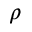<formula> <loc_0><loc_0><loc_500><loc_500>\rho</formula> 